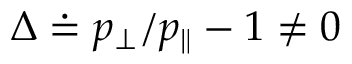Convert formula to latex. <formula><loc_0><loc_0><loc_500><loc_500>\Delta \doteq p _ { \perp } / p _ { \| } - 1 \ne 0</formula> 